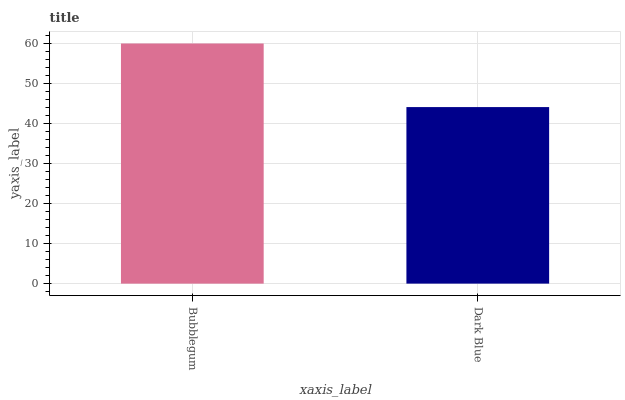Is Dark Blue the minimum?
Answer yes or no. Yes. Is Bubblegum the maximum?
Answer yes or no. Yes. Is Dark Blue the maximum?
Answer yes or no. No. Is Bubblegum greater than Dark Blue?
Answer yes or no. Yes. Is Dark Blue less than Bubblegum?
Answer yes or no. Yes. Is Dark Blue greater than Bubblegum?
Answer yes or no. No. Is Bubblegum less than Dark Blue?
Answer yes or no. No. Is Bubblegum the high median?
Answer yes or no. Yes. Is Dark Blue the low median?
Answer yes or no. Yes. Is Dark Blue the high median?
Answer yes or no. No. Is Bubblegum the low median?
Answer yes or no. No. 